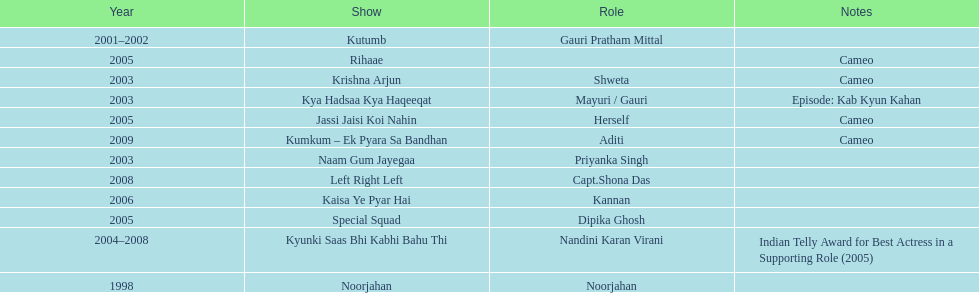How many shows were there in 2005? 3. 